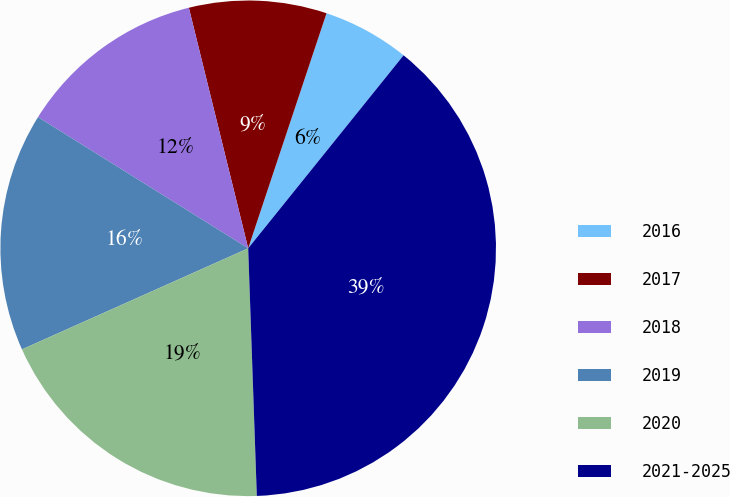Convert chart to OTSL. <chart><loc_0><loc_0><loc_500><loc_500><pie_chart><fcel>2016<fcel>2017<fcel>2018<fcel>2019<fcel>2020<fcel>2021-2025<nl><fcel>5.67%<fcel>8.97%<fcel>12.27%<fcel>15.57%<fcel>18.87%<fcel>38.66%<nl></chart> 